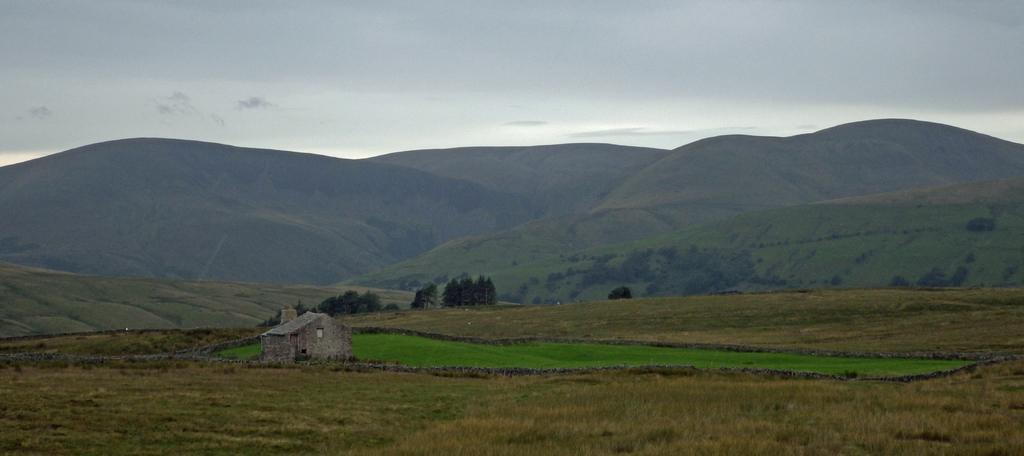What type of structure is visible in the image? There is a house in the image. What type of vegetation can be seen in the image? There are plants, grass, and trees visible in the image. What type of terrain is present in the image? There are hills visible in the image. What part of the natural environment is visible in the image? The sky is visible in the image. What type of rain can be seen falling in the image? There is no rain visible in the image; the sky is clear. 